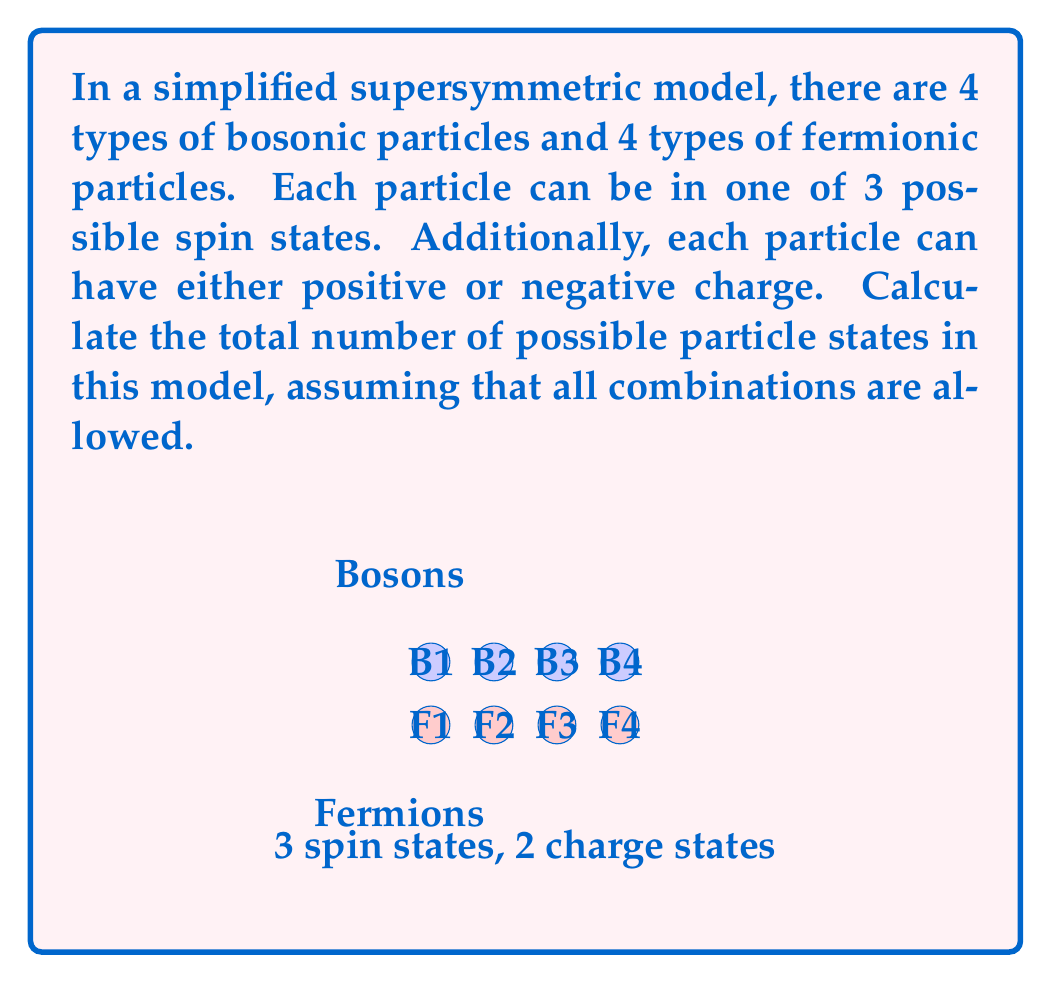Help me with this question. Let's approach this step-by-step:

1) First, let's consider the number of states for a single particle type:
   - 3 possible spin states
   - 2 possible charge states (positive or negative)
   
   So, for each particle type, there are $3 \times 2 = 6$ possible states.

2) Now, we have 4 types of bosonic particles and 4 types of fermionic particles.
   This means we have 8 particle types in total.

3) For each of these 8 particle types, we have 6 possible states.

4) To find the total number of possible states, we need to multiply the number of states for each particle type:

   $$ \text{Total States} = 6^8 $$

5) Let's calculate this:
   $$ 6^8 = 1,679,616 $$

This calculation uses the multiplication principle of combinatorics. We're essentially creating a combination of states across all particle types, where each particle type can be in any of its 6 possible states independently of the others.
Answer: $1,679,616$ 